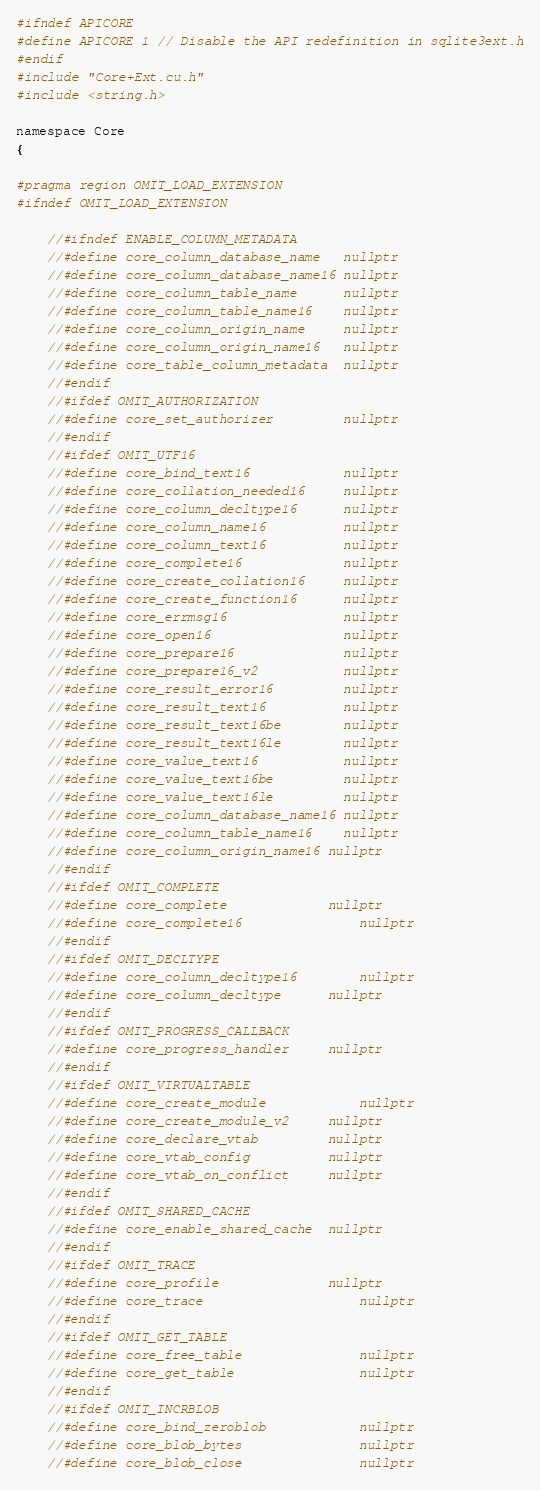Convert code to text. <code><loc_0><loc_0><loc_500><loc_500><_Cuda_>#ifndef APICORE
#define APICORE 1 // Disable the API redefinition in sqlite3ext.h
#endif
#include "Core+Ext.cu.h"
#include <string.h>

namespace Core
{

#pragma region OMIT_LOAD_EXTENSION
#ifndef OMIT_LOAD_EXTENSION

	//#ifndef ENABLE_COLUMN_METADATA
	//#define core_column_database_name   nullptr
	//#define core_column_database_name16 nullptr
	//#define core_column_table_name      nullptr
	//#define core_column_table_name16    nullptr
	//#define core_column_origin_name     nullptr
	//#define core_column_origin_name16   nullptr
	//#define core_table_column_metadata  nullptr
	//#endif
	//#ifdef OMIT_AUTHORIZATION
	//#define core_set_authorizer         nullptr
	//#endif
	//#ifdef OMIT_UTF16
	//#define core_bind_text16            nullptr
	//#define core_collation_needed16     nullptr
	//#define core_column_decltype16      nullptr
	//#define core_column_name16          nullptr
	//#define core_column_text16          nullptr
	//#define core_complete16             nullptr
	//#define core_create_collation16     nullptr
	//#define core_create_function16      nullptr
	//#define core_errmsg16               nullptr
	//#define core_open16                 nullptr
	//#define core_prepare16              nullptr
	//#define core_prepare16_v2           nullptr
	//#define core_result_error16         nullptr
	//#define core_result_text16          nullptr
	//#define core_result_text16be        nullptr
	//#define core_result_text16le        nullptr
	//#define core_value_text16           nullptr
	//#define core_value_text16be         nullptr
	//#define core_value_text16le         nullptr
	//#define core_column_database_name16 nullptr
	//#define core_column_table_name16    nullptr
	//#define core_column_origin_name16	nullptr
	//#endif
	//#ifdef OMIT_COMPLETE
	//#define core_complete				nullptr
	//#define core_complete16				nullptr
	//#endif
	//#ifdef OMIT_DECLTYPE
	//#define core_column_decltype16		nullptr
	//#define core_column_decltype		nullptr
	//#endif
	//#ifdef OMIT_PROGRESS_CALLBACK
	//#define core_progress_handler		nullptr
	//#endif
	//#ifdef OMIT_VIRTUALTABLE
	//#define core_create_module			nullptr
	//#define core_create_module_v2		nullptr
	//#define core_declare_vtab			nullptr
	//#define core_vtab_config			nullptr
	//#define core_vtab_on_conflict		nullptr
	//#endif
	//#ifdef OMIT_SHARED_CACHE
	//#define core_enable_shared_cache	nullptr
	//#endif
	//#ifdef OMIT_TRACE
	//#define core_profile				nullptr
	//#define core_trace					nullptr
	//#endif
	//#ifdef OMIT_GET_TABLE
	//#define core_free_table				nullptr
	//#define core_get_table				nullptr
	//#endif
	//#ifdef OMIT_INCRBLOB
	//#define core_bind_zeroblob			nullptr
	//#define core_blob_bytes				nullptr
	//#define core_blob_close				nullptr</code> 